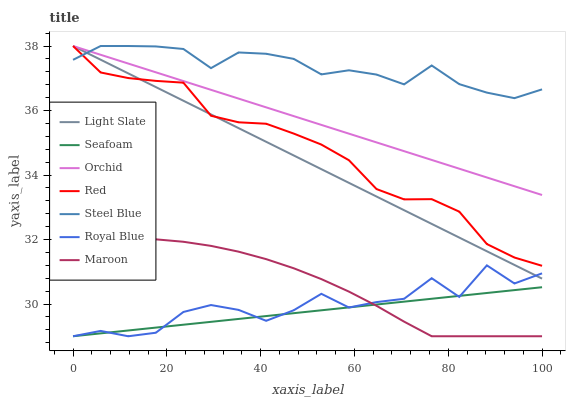Does Seafoam have the minimum area under the curve?
Answer yes or no. Yes. Does Steel Blue have the maximum area under the curve?
Answer yes or no. Yes. Does Maroon have the minimum area under the curve?
Answer yes or no. No. Does Maroon have the maximum area under the curve?
Answer yes or no. No. Is Seafoam the smoothest?
Answer yes or no. Yes. Is Royal Blue the roughest?
Answer yes or no. Yes. Is Steel Blue the smoothest?
Answer yes or no. No. Is Steel Blue the roughest?
Answer yes or no. No. Does Steel Blue have the lowest value?
Answer yes or no. No. Does Orchid have the highest value?
Answer yes or no. Yes. Does Maroon have the highest value?
Answer yes or no. No. Is Royal Blue less than Steel Blue?
Answer yes or no. Yes. Is Light Slate greater than Seafoam?
Answer yes or no. Yes. Does Light Slate intersect Orchid?
Answer yes or no. Yes. Is Light Slate less than Orchid?
Answer yes or no. No. Is Light Slate greater than Orchid?
Answer yes or no. No. Does Royal Blue intersect Steel Blue?
Answer yes or no. No. 